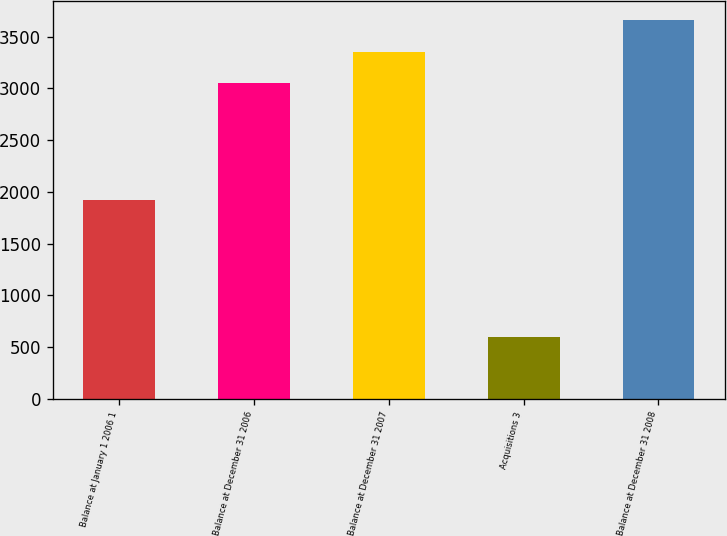Convert chart to OTSL. <chart><loc_0><loc_0><loc_500><loc_500><bar_chart><fcel>Balance at January 1 2006 1<fcel>Balance at December 31 2006<fcel>Balance at December 31 2007<fcel>Acquisitions 3<fcel>Balance at December 31 2008<nl><fcel>1924<fcel>3047<fcel>3351.6<fcel>601<fcel>3656.2<nl></chart> 